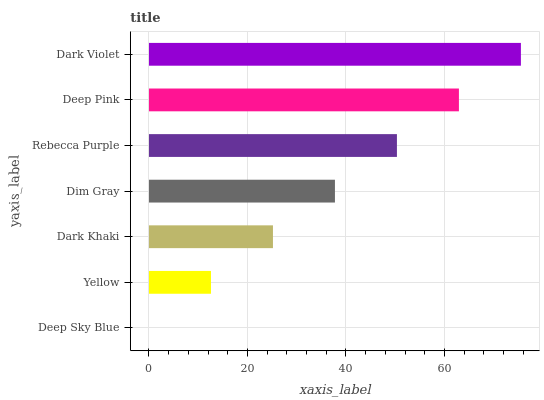Is Deep Sky Blue the minimum?
Answer yes or no. Yes. Is Dark Violet the maximum?
Answer yes or no. Yes. Is Yellow the minimum?
Answer yes or no. No. Is Yellow the maximum?
Answer yes or no. No. Is Yellow greater than Deep Sky Blue?
Answer yes or no. Yes. Is Deep Sky Blue less than Yellow?
Answer yes or no. Yes. Is Deep Sky Blue greater than Yellow?
Answer yes or no. No. Is Yellow less than Deep Sky Blue?
Answer yes or no. No. Is Dim Gray the high median?
Answer yes or no. Yes. Is Dim Gray the low median?
Answer yes or no. Yes. Is Dark Khaki the high median?
Answer yes or no. No. Is Dark Violet the low median?
Answer yes or no. No. 